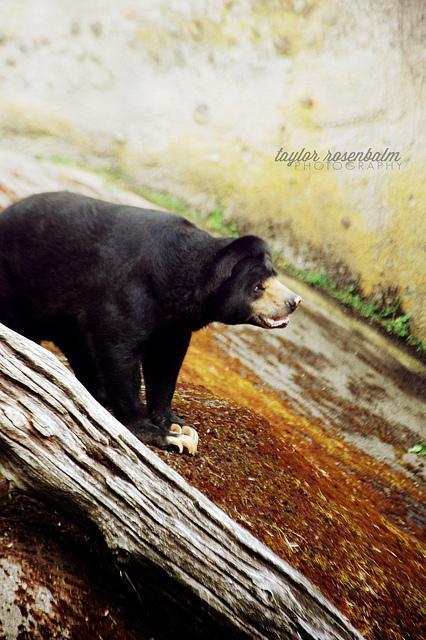How many bears can be seen?
Give a very brief answer. 1. How many trains are there?
Give a very brief answer. 0. 